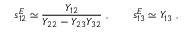Convert formula to latex. <formula><loc_0><loc_0><loc_500><loc_500>s _ { 1 2 } ^ { E } \simeq \frac { Y _ { 1 2 } } { Y _ { 2 2 } - Y _ { 2 3 } Y _ { 3 2 } } \ , \quad s _ { 1 3 } ^ { E } \simeq Y _ { 1 3 } \ ,</formula> 